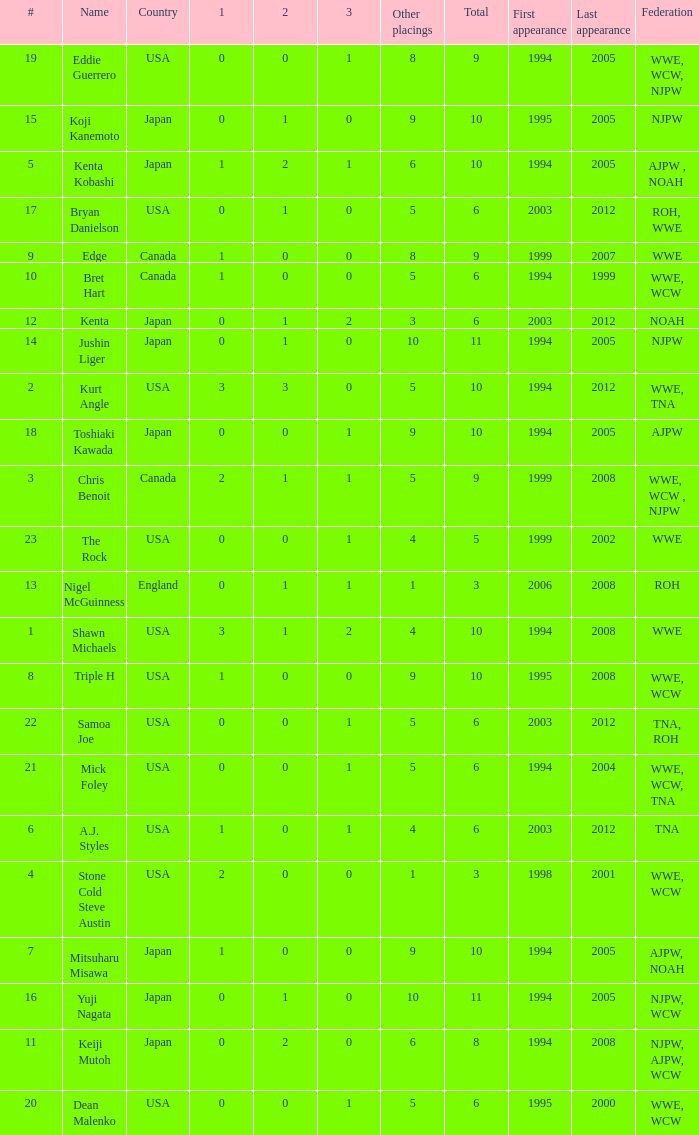How many times has a wrestler whose federation was roh, wwe competed in this event? 1.0. Could you parse the entire table? {'header': ['#', 'Name', 'Country', '1', '2', '3', 'Other placings', 'Total', 'First appearance', 'Last appearance', 'Federation'], 'rows': [['19', 'Eddie Guerrero', 'USA', '0', '0', '1', '8', '9', '1994', '2005', 'WWE, WCW, NJPW'], ['15', 'Koji Kanemoto', 'Japan', '0', '1', '0', '9', '10', '1995', '2005', 'NJPW'], ['5', 'Kenta Kobashi', 'Japan', '1', '2', '1', '6', '10', '1994', '2005', 'AJPW , NOAH'], ['17', 'Bryan Danielson', 'USA', '0', '1', '0', '5', '6', '2003', '2012', 'ROH, WWE'], ['9', 'Edge', 'Canada', '1', '0', '0', '8', '9', '1999', '2007', 'WWE'], ['10', 'Bret Hart', 'Canada', '1', '0', '0', '5', '6', '1994', '1999', 'WWE, WCW'], ['12', 'Kenta', 'Japan', '0', '1', '2', '3', '6', '2003', '2012', 'NOAH'], ['14', 'Jushin Liger', 'Japan', '0', '1', '0', '10', '11', '1994', '2005', 'NJPW'], ['2', 'Kurt Angle', 'USA', '3', '3', '0', '5', '10', '1994', '2012', 'WWE, TNA'], ['18', 'Toshiaki Kawada', 'Japan', '0', '0', '1', '9', '10', '1994', '2005', 'AJPW'], ['3', 'Chris Benoit', 'Canada', '2', '1', '1', '5', '9', '1999', '2008', 'WWE, WCW , NJPW'], ['23', 'The Rock', 'USA', '0', '0', '1', '4', '5', '1999', '2002', 'WWE'], ['13', 'Nigel McGuinness', 'England', '0', '1', '1', '1', '3', '2006', '2008', 'ROH'], ['1', 'Shawn Michaels', 'USA', '3', '1', '2', '4', '10', '1994', '2008', 'WWE'], ['8', 'Triple H', 'USA', '1', '0', '0', '9', '10', '1995', '2008', 'WWE, WCW'], ['22', 'Samoa Joe', 'USA', '0', '0', '1', '5', '6', '2003', '2012', 'TNA, ROH'], ['21', 'Mick Foley', 'USA', '0', '0', '1', '5', '6', '1994', '2004', 'WWE, WCW, TNA'], ['6', 'A.J. Styles', 'USA', '1', '0', '1', '4', '6', '2003', '2012', 'TNA'], ['4', 'Stone Cold Steve Austin', 'USA', '2', '0', '0', '1', '3', '1998', '2001', 'WWE, WCW'], ['7', 'Mitsuharu Misawa', 'Japan', '1', '0', '0', '9', '10', '1994', '2005', 'AJPW, NOAH'], ['16', 'Yuji Nagata', 'Japan', '0', '1', '0', '10', '11', '1994', '2005', 'NJPW, WCW'], ['11', 'Keiji Mutoh', 'Japan', '0', '2', '0', '6', '8', '1994', '2008', 'NJPW, AJPW, WCW'], ['20', 'Dean Malenko', 'USA', '0', '0', '1', '5', '6', '1995', '2000', 'WWE, WCW']]} 